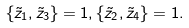<formula> <loc_0><loc_0><loc_500><loc_500>\{ { \tilde { z } _ { 1 } } , { \tilde { z } _ { 3 } } \} = 1 , \{ { \tilde { z } _ { 2 } } , { \tilde { z } _ { 4 } } \} = 1 .</formula> 